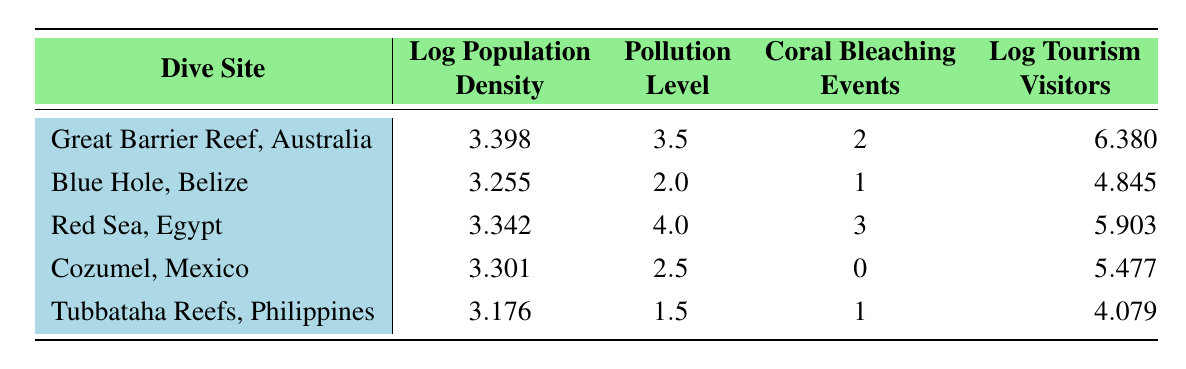What is the log population density of the Great Barrier Reef, Australia? From the table, we can see the population density for the Great Barrier Reef is specifically mentioned under the "Log Population Density" column, which is 3.398.
Answer: 3.398 How many coral bleaching events have occurred at the Red Sea, Egypt? The table shows the number of coral bleaching events for the Red Sea is listed under the corresponding column, with a value of 3.
Answer: 3 Which dive site has the highest pollution level? By observing the "Pollution Level" column, the Red Sea has the highest value at 4.0 compared to the other sites listed.
Answer: Red Sea, Egypt What is the average log tourism visitors across all dive sites? To find the average, we sum the log tourism visitors: 6.380 + 4.845 + 5.903 + 5.477 + 4.079 = 26.684. Then we divide by the number of sites (5), leading to an average of 26.684/5 = 5.337.
Answer: 5.337 Is the population density of Tubbataha Reefs, Philippines higher than that of Blue Hole, Belize? We compare the population densities: Tubbataha has 1500 while Blue Hole has 1800. Since 1500 < 1800, the statement is false.
Answer: No What is the total number of coral bleaching events recorded across all dive sites? To calculate the total, we add the number of coral bleaching events: 2 (Great Barrier Reef) + 1 (Blue Hole) + 3 (Red Sea) + 0 (Cozumel) + 1 (Tubbataha) = 7.
Answer: 7 How does the log population density of Cozumel, Mexico compare to that of the Great Barrier Reef, Australia? The log population density of Cozumel is 3.301, which is less than that of the Great Barrier Reef at 3.398. This shows that Cozumel has a lower density.
Answer: Lower Is it true that the Blue Hole, Belize has a lower pollution level than Tubbataha Reefs, Philippines? The pollution levels are 2.0 for Blue Hole and 1.5 for Tubbataha. Since 2.0 > 1.5, the statement is false.
Answer: No Which dive site has the least number of tourism visitors logged? By examining the "Log Tourism Visitors" column, Tubbataha Reefs has the lowest value at 4.079 compared to the others, so it has the least visitors logged.
Answer: Tubbataha Reefs, Philippines 